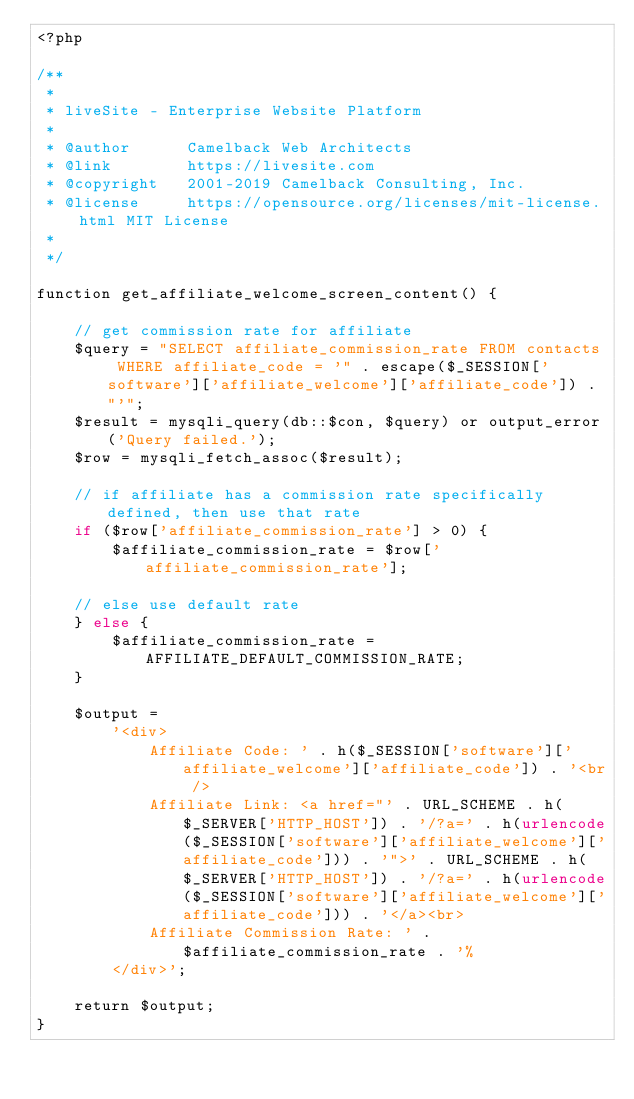Convert code to text. <code><loc_0><loc_0><loc_500><loc_500><_PHP_><?php

/**
 *
 * liveSite - Enterprise Website Platform
 * 
 * @author      Camelback Web Architects
 * @link        https://livesite.com
 * @copyright   2001-2019 Camelback Consulting, Inc.
 * @license     https://opensource.org/licenses/mit-license.html MIT License
 *
 */

function get_affiliate_welcome_screen_content() {

    // get commission rate for affiliate
    $query = "SELECT affiliate_commission_rate FROM contacts WHERE affiliate_code = '" . escape($_SESSION['software']['affiliate_welcome']['affiliate_code']) . "'";
    $result = mysqli_query(db::$con, $query) or output_error('Query failed.');
    $row = mysqli_fetch_assoc($result);
    
    // if affiliate has a commission rate specifically defined, then use that rate
    if ($row['affiliate_commission_rate'] > 0) {
        $affiliate_commission_rate = $row['affiliate_commission_rate'];
        
    // else use default rate
    } else {
        $affiliate_commission_rate = AFFILIATE_DEFAULT_COMMISSION_RATE;
    }
    
    $output =
        '<div>
            Affiliate Code: ' . h($_SESSION['software']['affiliate_welcome']['affiliate_code']) . '<br />
            Affiliate Link: <a href="' . URL_SCHEME . h($_SERVER['HTTP_HOST']) . '/?a=' . h(urlencode($_SESSION['software']['affiliate_welcome']['affiliate_code'])) . '">' . URL_SCHEME . h($_SERVER['HTTP_HOST']) . '/?a=' . h(urlencode($_SESSION['software']['affiliate_welcome']['affiliate_code'])) . '</a><br>
            Affiliate Commission Rate: ' . $affiliate_commission_rate . '%
        </div>';

    return $output;
}</code> 